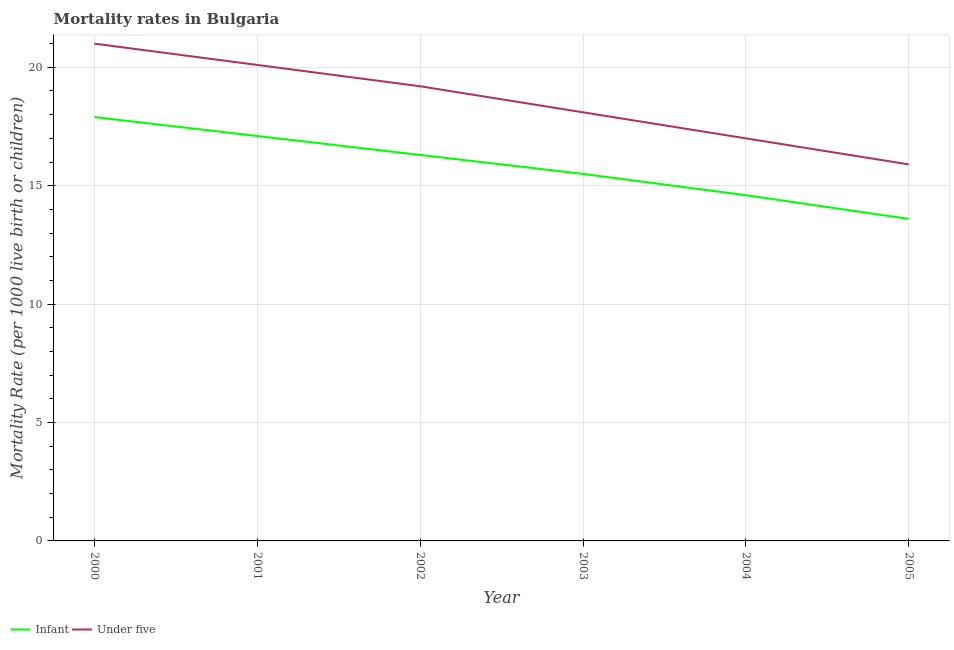How many different coloured lines are there?
Provide a succinct answer. 2. Is the number of lines equal to the number of legend labels?
Make the answer very short. Yes. What is the infant mortality rate in 2000?
Your answer should be compact. 17.9. What is the total under-5 mortality rate in the graph?
Keep it short and to the point. 111.3. What is the difference between the infant mortality rate in 2001 and that in 2002?
Give a very brief answer. 0.8. What is the difference between the infant mortality rate in 2003 and the under-5 mortality rate in 2002?
Provide a succinct answer. -3.7. What is the average infant mortality rate per year?
Provide a short and direct response. 15.83. In the year 2004, what is the difference between the infant mortality rate and under-5 mortality rate?
Offer a very short reply. -2.4. What is the ratio of the infant mortality rate in 2000 to that in 2002?
Give a very brief answer. 1.1. Is the under-5 mortality rate in 2000 less than that in 2005?
Your response must be concise. No. Is the difference between the infant mortality rate in 2002 and 2003 greater than the difference between the under-5 mortality rate in 2002 and 2003?
Your response must be concise. No. What is the difference between the highest and the second highest infant mortality rate?
Ensure brevity in your answer.  0.8. What is the difference between the highest and the lowest under-5 mortality rate?
Provide a succinct answer. 5.1. In how many years, is the infant mortality rate greater than the average infant mortality rate taken over all years?
Give a very brief answer. 3. Does the infant mortality rate monotonically increase over the years?
Your response must be concise. No. Is the under-5 mortality rate strictly less than the infant mortality rate over the years?
Ensure brevity in your answer.  No. What is the difference between two consecutive major ticks on the Y-axis?
Provide a short and direct response. 5. Are the values on the major ticks of Y-axis written in scientific E-notation?
Make the answer very short. No. Where does the legend appear in the graph?
Provide a short and direct response. Bottom left. How many legend labels are there?
Give a very brief answer. 2. How are the legend labels stacked?
Keep it short and to the point. Horizontal. What is the title of the graph?
Your answer should be compact. Mortality rates in Bulgaria. Does "Male population" appear as one of the legend labels in the graph?
Your response must be concise. No. What is the label or title of the X-axis?
Your answer should be very brief. Year. What is the label or title of the Y-axis?
Provide a succinct answer. Mortality Rate (per 1000 live birth or children). What is the Mortality Rate (per 1000 live birth or children) in Infant in 2000?
Make the answer very short. 17.9. What is the Mortality Rate (per 1000 live birth or children) in Infant in 2001?
Give a very brief answer. 17.1. What is the Mortality Rate (per 1000 live birth or children) in Under five in 2001?
Ensure brevity in your answer.  20.1. What is the Mortality Rate (per 1000 live birth or children) of Infant in 2002?
Your answer should be very brief. 16.3. What is the Mortality Rate (per 1000 live birth or children) of Under five in 2004?
Offer a terse response. 17. What is the Mortality Rate (per 1000 live birth or children) in Infant in 2005?
Your response must be concise. 13.6. Across all years, what is the maximum Mortality Rate (per 1000 live birth or children) in Under five?
Provide a short and direct response. 21. What is the total Mortality Rate (per 1000 live birth or children) of Infant in the graph?
Keep it short and to the point. 95. What is the total Mortality Rate (per 1000 live birth or children) in Under five in the graph?
Your answer should be compact. 111.3. What is the difference between the Mortality Rate (per 1000 live birth or children) of Infant in 2000 and that in 2001?
Make the answer very short. 0.8. What is the difference between the Mortality Rate (per 1000 live birth or children) in Under five in 2000 and that in 2001?
Provide a succinct answer. 0.9. What is the difference between the Mortality Rate (per 1000 live birth or children) in Infant in 2000 and that in 2002?
Provide a short and direct response. 1.6. What is the difference between the Mortality Rate (per 1000 live birth or children) of Under five in 2000 and that in 2002?
Your response must be concise. 1.8. What is the difference between the Mortality Rate (per 1000 live birth or children) in Under five in 2000 and that in 2003?
Your response must be concise. 2.9. What is the difference between the Mortality Rate (per 1000 live birth or children) of Infant in 2000 and that in 2005?
Offer a terse response. 4.3. What is the difference between the Mortality Rate (per 1000 live birth or children) in Under five in 2000 and that in 2005?
Keep it short and to the point. 5.1. What is the difference between the Mortality Rate (per 1000 live birth or children) in Under five in 2001 and that in 2002?
Ensure brevity in your answer.  0.9. What is the difference between the Mortality Rate (per 1000 live birth or children) in Infant in 2001 and that in 2004?
Provide a short and direct response. 2.5. What is the difference between the Mortality Rate (per 1000 live birth or children) in Under five in 2001 and that in 2004?
Keep it short and to the point. 3.1. What is the difference between the Mortality Rate (per 1000 live birth or children) of Infant in 2001 and that in 2005?
Offer a very short reply. 3.5. What is the difference between the Mortality Rate (per 1000 live birth or children) in Under five in 2001 and that in 2005?
Give a very brief answer. 4.2. What is the difference between the Mortality Rate (per 1000 live birth or children) of Infant in 2002 and that in 2003?
Keep it short and to the point. 0.8. What is the difference between the Mortality Rate (per 1000 live birth or children) in Infant in 2002 and that in 2004?
Provide a succinct answer. 1.7. What is the difference between the Mortality Rate (per 1000 live birth or children) of Infant in 2002 and that in 2005?
Your answer should be compact. 2.7. What is the difference between the Mortality Rate (per 1000 live birth or children) in Under five in 2002 and that in 2005?
Provide a succinct answer. 3.3. What is the difference between the Mortality Rate (per 1000 live birth or children) in Infant in 2003 and that in 2004?
Give a very brief answer. 0.9. What is the difference between the Mortality Rate (per 1000 live birth or children) in Under five in 2003 and that in 2004?
Ensure brevity in your answer.  1.1. What is the difference between the Mortality Rate (per 1000 live birth or children) of Infant in 2003 and that in 2005?
Make the answer very short. 1.9. What is the difference between the Mortality Rate (per 1000 live birth or children) of Under five in 2003 and that in 2005?
Give a very brief answer. 2.2. What is the difference between the Mortality Rate (per 1000 live birth or children) of Under five in 2004 and that in 2005?
Offer a terse response. 1.1. What is the difference between the Mortality Rate (per 1000 live birth or children) in Infant in 2000 and the Mortality Rate (per 1000 live birth or children) in Under five in 2002?
Offer a terse response. -1.3. What is the difference between the Mortality Rate (per 1000 live birth or children) in Infant in 2000 and the Mortality Rate (per 1000 live birth or children) in Under five in 2003?
Provide a short and direct response. -0.2. What is the difference between the Mortality Rate (per 1000 live birth or children) of Infant in 2000 and the Mortality Rate (per 1000 live birth or children) of Under five in 2004?
Make the answer very short. 0.9. What is the difference between the Mortality Rate (per 1000 live birth or children) in Infant in 2001 and the Mortality Rate (per 1000 live birth or children) in Under five in 2005?
Provide a short and direct response. 1.2. What is the difference between the Mortality Rate (per 1000 live birth or children) in Infant in 2002 and the Mortality Rate (per 1000 live birth or children) in Under five in 2005?
Offer a terse response. 0.4. What is the difference between the Mortality Rate (per 1000 live birth or children) in Infant in 2004 and the Mortality Rate (per 1000 live birth or children) in Under five in 2005?
Your answer should be very brief. -1.3. What is the average Mortality Rate (per 1000 live birth or children) of Infant per year?
Ensure brevity in your answer.  15.83. What is the average Mortality Rate (per 1000 live birth or children) in Under five per year?
Keep it short and to the point. 18.55. In the year 2000, what is the difference between the Mortality Rate (per 1000 live birth or children) of Infant and Mortality Rate (per 1000 live birth or children) of Under five?
Provide a short and direct response. -3.1. In the year 2002, what is the difference between the Mortality Rate (per 1000 live birth or children) in Infant and Mortality Rate (per 1000 live birth or children) in Under five?
Ensure brevity in your answer.  -2.9. What is the ratio of the Mortality Rate (per 1000 live birth or children) in Infant in 2000 to that in 2001?
Your answer should be very brief. 1.05. What is the ratio of the Mortality Rate (per 1000 live birth or children) in Under five in 2000 to that in 2001?
Offer a very short reply. 1.04. What is the ratio of the Mortality Rate (per 1000 live birth or children) in Infant in 2000 to that in 2002?
Provide a short and direct response. 1.1. What is the ratio of the Mortality Rate (per 1000 live birth or children) of Under five in 2000 to that in 2002?
Offer a very short reply. 1.09. What is the ratio of the Mortality Rate (per 1000 live birth or children) in Infant in 2000 to that in 2003?
Provide a short and direct response. 1.15. What is the ratio of the Mortality Rate (per 1000 live birth or children) of Under five in 2000 to that in 2003?
Keep it short and to the point. 1.16. What is the ratio of the Mortality Rate (per 1000 live birth or children) in Infant in 2000 to that in 2004?
Ensure brevity in your answer.  1.23. What is the ratio of the Mortality Rate (per 1000 live birth or children) in Under five in 2000 to that in 2004?
Your answer should be very brief. 1.24. What is the ratio of the Mortality Rate (per 1000 live birth or children) in Infant in 2000 to that in 2005?
Your answer should be very brief. 1.32. What is the ratio of the Mortality Rate (per 1000 live birth or children) of Under five in 2000 to that in 2005?
Give a very brief answer. 1.32. What is the ratio of the Mortality Rate (per 1000 live birth or children) in Infant in 2001 to that in 2002?
Make the answer very short. 1.05. What is the ratio of the Mortality Rate (per 1000 live birth or children) in Under five in 2001 to that in 2002?
Your answer should be very brief. 1.05. What is the ratio of the Mortality Rate (per 1000 live birth or children) in Infant in 2001 to that in 2003?
Offer a very short reply. 1.1. What is the ratio of the Mortality Rate (per 1000 live birth or children) in Under five in 2001 to that in 2003?
Ensure brevity in your answer.  1.11. What is the ratio of the Mortality Rate (per 1000 live birth or children) in Infant in 2001 to that in 2004?
Offer a terse response. 1.17. What is the ratio of the Mortality Rate (per 1000 live birth or children) of Under five in 2001 to that in 2004?
Provide a succinct answer. 1.18. What is the ratio of the Mortality Rate (per 1000 live birth or children) in Infant in 2001 to that in 2005?
Your answer should be compact. 1.26. What is the ratio of the Mortality Rate (per 1000 live birth or children) of Under five in 2001 to that in 2005?
Provide a succinct answer. 1.26. What is the ratio of the Mortality Rate (per 1000 live birth or children) in Infant in 2002 to that in 2003?
Ensure brevity in your answer.  1.05. What is the ratio of the Mortality Rate (per 1000 live birth or children) in Under five in 2002 to that in 2003?
Your answer should be very brief. 1.06. What is the ratio of the Mortality Rate (per 1000 live birth or children) of Infant in 2002 to that in 2004?
Keep it short and to the point. 1.12. What is the ratio of the Mortality Rate (per 1000 live birth or children) in Under five in 2002 to that in 2004?
Your response must be concise. 1.13. What is the ratio of the Mortality Rate (per 1000 live birth or children) in Infant in 2002 to that in 2005?
Ensure brevity in your answer.  1.2. What is the ratio of the Mortality Rate (per 1000 live birth or children) in Under five in 2002 to that in 2005?
Keep it short and to the point. 1.21. What is the ratio of the Mortality Rate (per 1000 live birth or children) in Infant in 2003 to that in 2004?
Keep it short and to the point. 1.06. What is the ratio of the Mortality Rate (per 1000 live birth or children) in Under five in 2003 to that in 2004?
Keep it short and to the point. 1.06. What is the ratio of the Mortality Rate (per 1000 live birth or children) in Infant in 2003 to that in 2005?
Your answer should be very brief. 1.14. What is the ratio of the Mortality Rate (per 1000 live birth or children) in Under five in 2003 to that in 2005?
Keep it short and to the point. 1.14. What is the ratio of the Mortality Rate (per 1000 live birth or children) of Infant in 2004 to that in 2005?
Your answer should be very brief. 1.07. What is the ratio of the Mortality Rate (per 1000 live birth or children) in Under five in 2004 to that in 2005?
Provide a short and direct response. 1.07. What is the difference between the highest and the second highest Mortality Rate (per 1000 live birth or children) in Infant?
Your answer should be compact. 0.8. What is the difference between the highest and the lowest Mortality Rate (per 1000 live birth or children) in Under five?
Offer a very short reply. 5.1. 